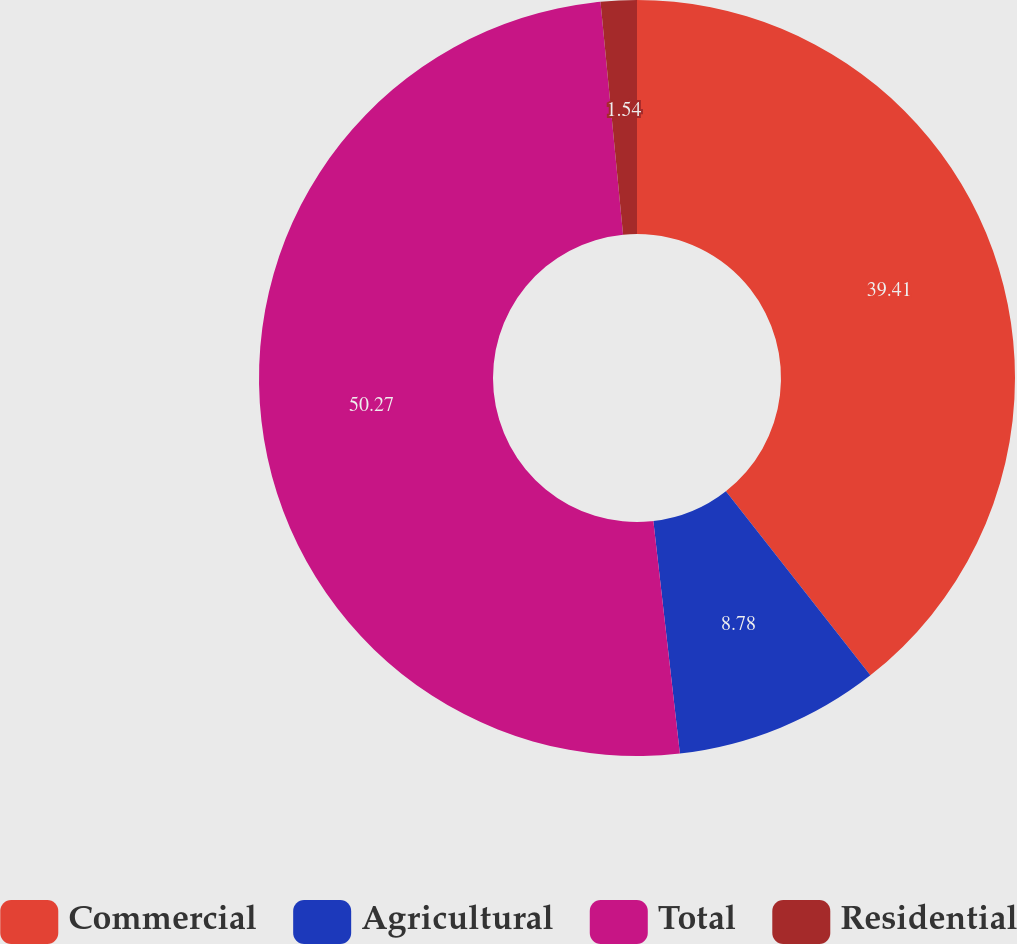Convert chart to OTSL. <chart><loc_0><loc_0><loc_500><loc_500><pie_chart><fcel>Commercial<fcel>Agricultural<fcel>Total<fcel>Residential<nl><fcel>39.41%<fcel>8.78%<fcel>50.27%<fcel>1.54%<nl></chart> 